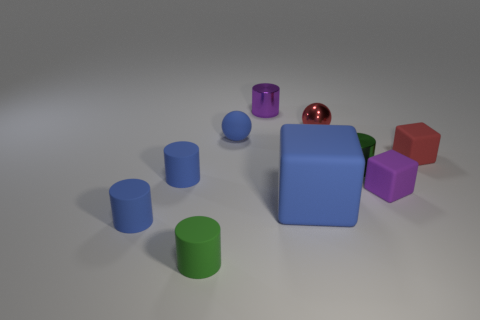There is a large object in front of the red rubber block; is its color the same as the tiny metallic cylinder that is to the right of the small purple cylinder?
Keep it short and to the point. No. The small green thing that is in front of the blue rubber thing right of the purple cylinder is what shape?
Make the answer very short. Cylinder. Are there any red cylinders of the same size as the purple cube?
Make the answer very short. No. How many other blue things have the same shape as the big object?
Ensure brevity in your answer.  0. Are there an equal number of tiny cubes to the left of the matte sphere and red metallic balls that are left of the small green rubber cylinder?
Offer a very short reply. Yes. Are there any gray shiny balls?
Your answer should be compact. No. There is a ball to the right of the metal cylinder that is behind the green thing that is on the right side of the tiny green matte cylinder; what size is it?
Offer a terse response. Small. There is a red shiny object that is the same size as the green shiny thing; what shape is it?
Offer a very short reply. Sphere. Is there any other thing that is the same material as the purple block?
Your answer should be compact. Yes. What number of objects are either small shiny cylinders behind the large blue rubber cube or red things?
Your answer should be very brief. 4. 